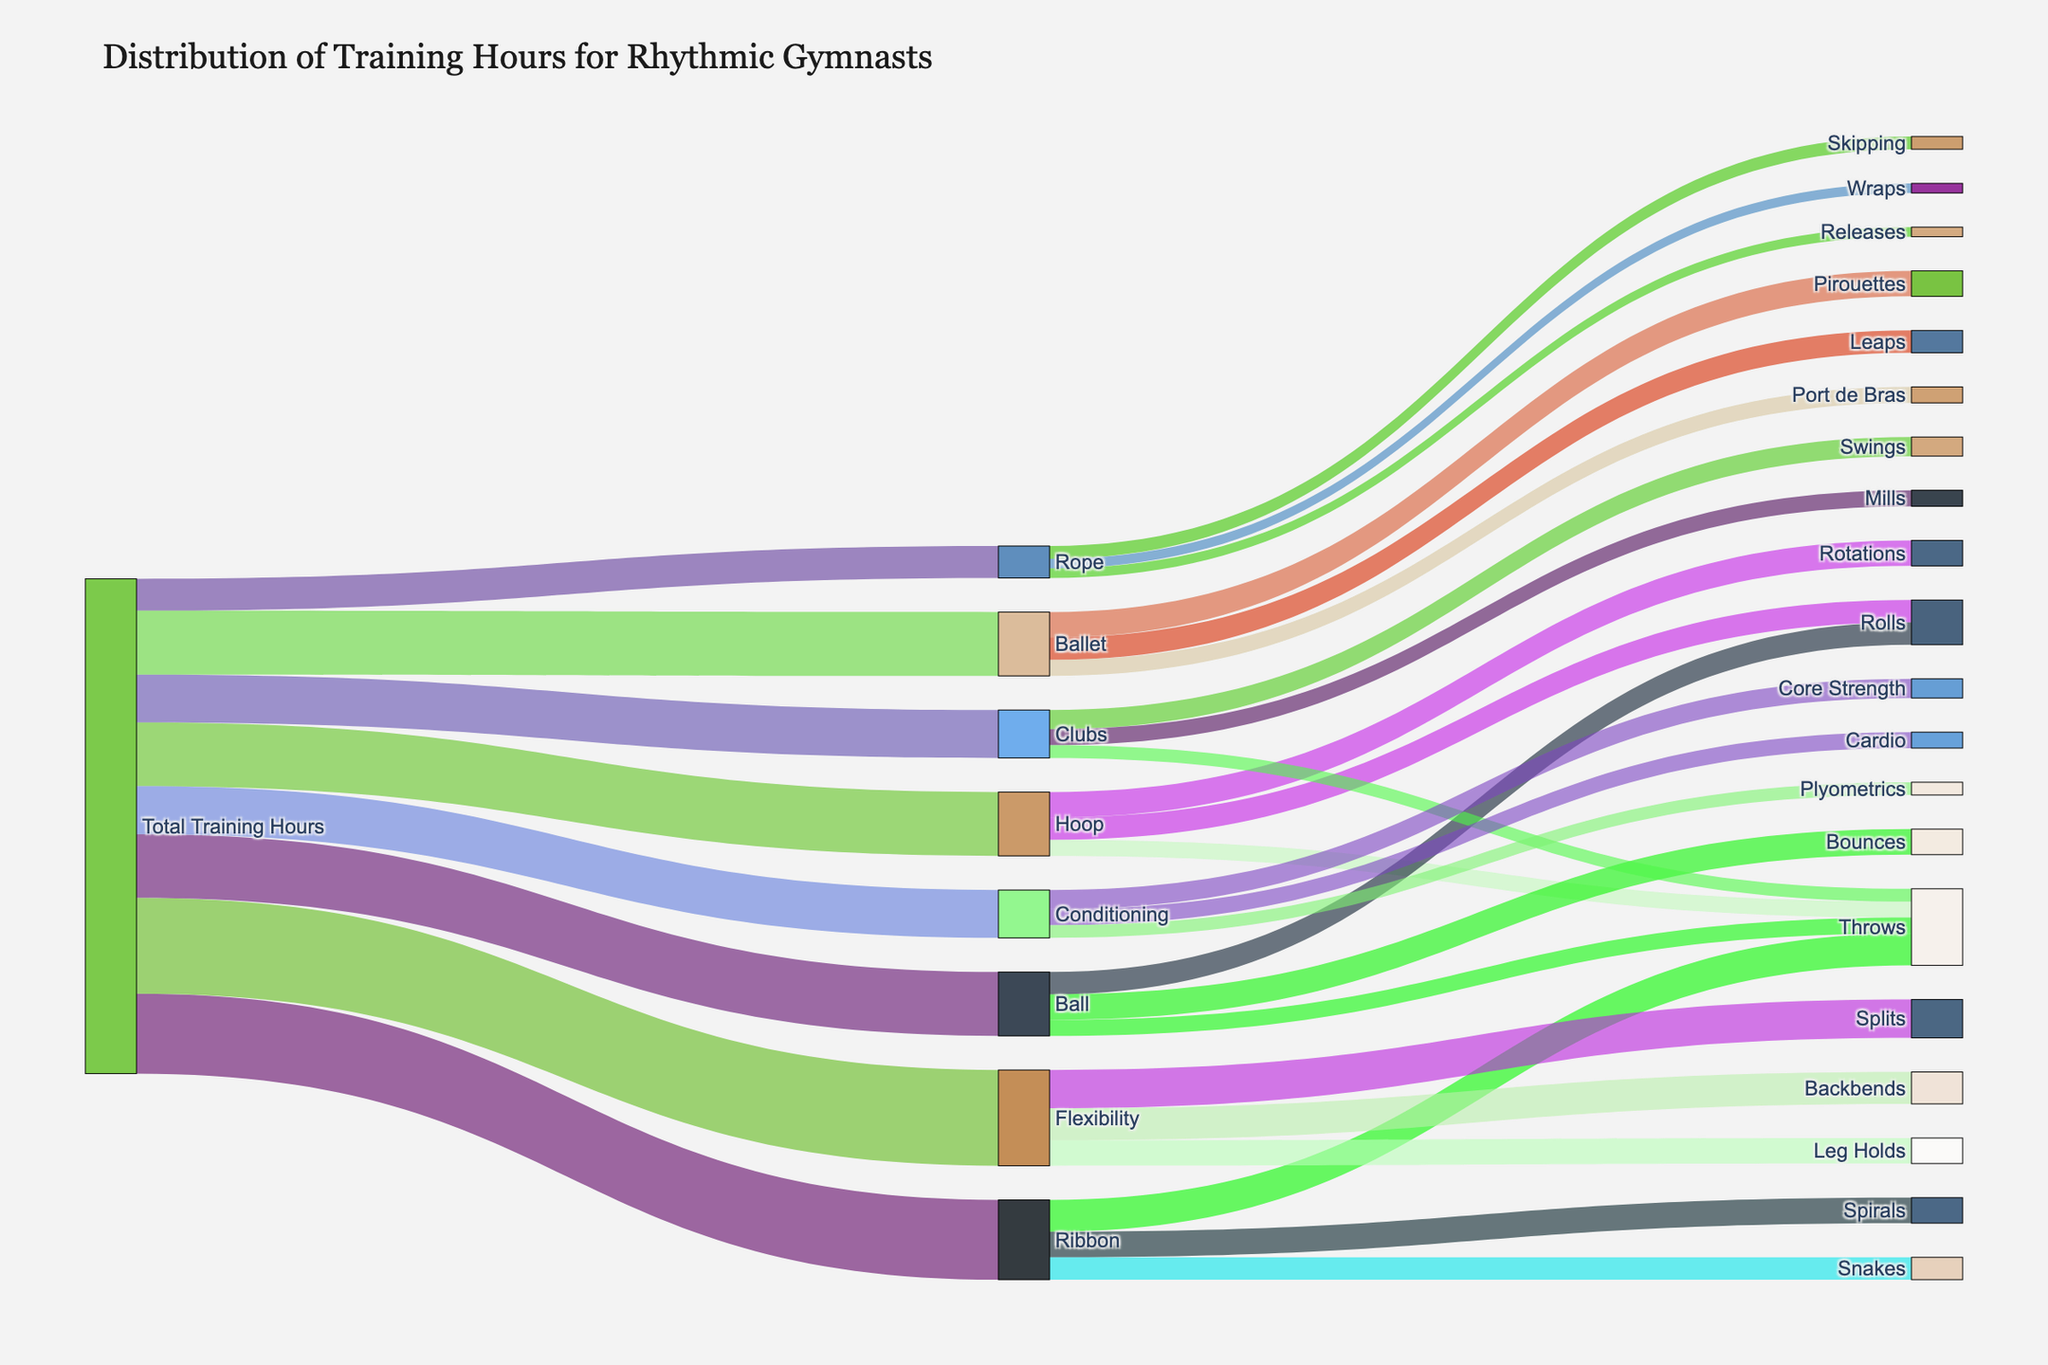What is the total number of training hours dedicated to Ribbon? The total number of training hours dedicated to Ribbon can be directly seen from the figure where Ribbon connects from Total Training Hours with a value of 25.
Answer: 25 How many hours are spent on Ballet training? The figure shows that Ballet has a direct connection from Total Training Hours with a value of 20.
Answer: 20 What is the combined total of training hours for Ball, Hoop, and Clubs? The training hours for Ball, Hoop, and Clubs are 20, 20, and 15, respectively. Adding these values: 20 + 20 + 15 = 55.
Answer: 55 Which skill under Ribbon has the lowest number of training hours, and how many hours are these? Ribbon has three skills: Throws (10), Spirals (8), and Snakes (7). The lowest is Snakes with 7 hours.
Answer: Snakes, 7 Compare the training hours for Flexibility versus Conditioning. Which one has more hours and by how much? Flexibility has 30 hours while Conditioning has 15 hours. The difference is 30 - 15 = 15. Therefore, Flexibility has 15 more hours than Conditioning.
Answer: Flexibility, 15 Which apparatus has training hours equivalent to those used for Ballet training? Ballet has 20 training hours. Both Ball and Hoop have the same amount, which is also 20 hours each.
Answer: Ball and Hoop Are there more total hours spent on specific Ribbon skills or on Ballet training?. If so, by how much? The specific Ribbon skills add up to: Throws (10) + Spirals (8) + Snakes (7) = 25. Ballet training hours are 20. The difference is 25 - 20 = 5 hours more spent on Ribbon skills.
Answer: Ribbon skills, 5 What percentage of Flexibility training hours is dedicated to Splits? Flexibility training hours are 30, and 12 hours are dedicated to Splits. The percentage is (12/30) * 100 = 40%.
Answer: 40% Which skill under Clubs takes the most and least training hours and what are these hours? Under Clubs, Swings take 6 hours, Mills take 5 hours, and Throws take 4 hours. The most is Swings with 6 hours, and the least is Throws with 4 hours.
Answer: Most: Swings, 6; Least: Throws, 4 Among the flexibility skills, which one has the highest training hours and what are the hours? The flexibility skills include Splits (12), Backbends (10), and Leg Holds (8). Splits has the highest with 12 hours.
Answer: Splits, 12 